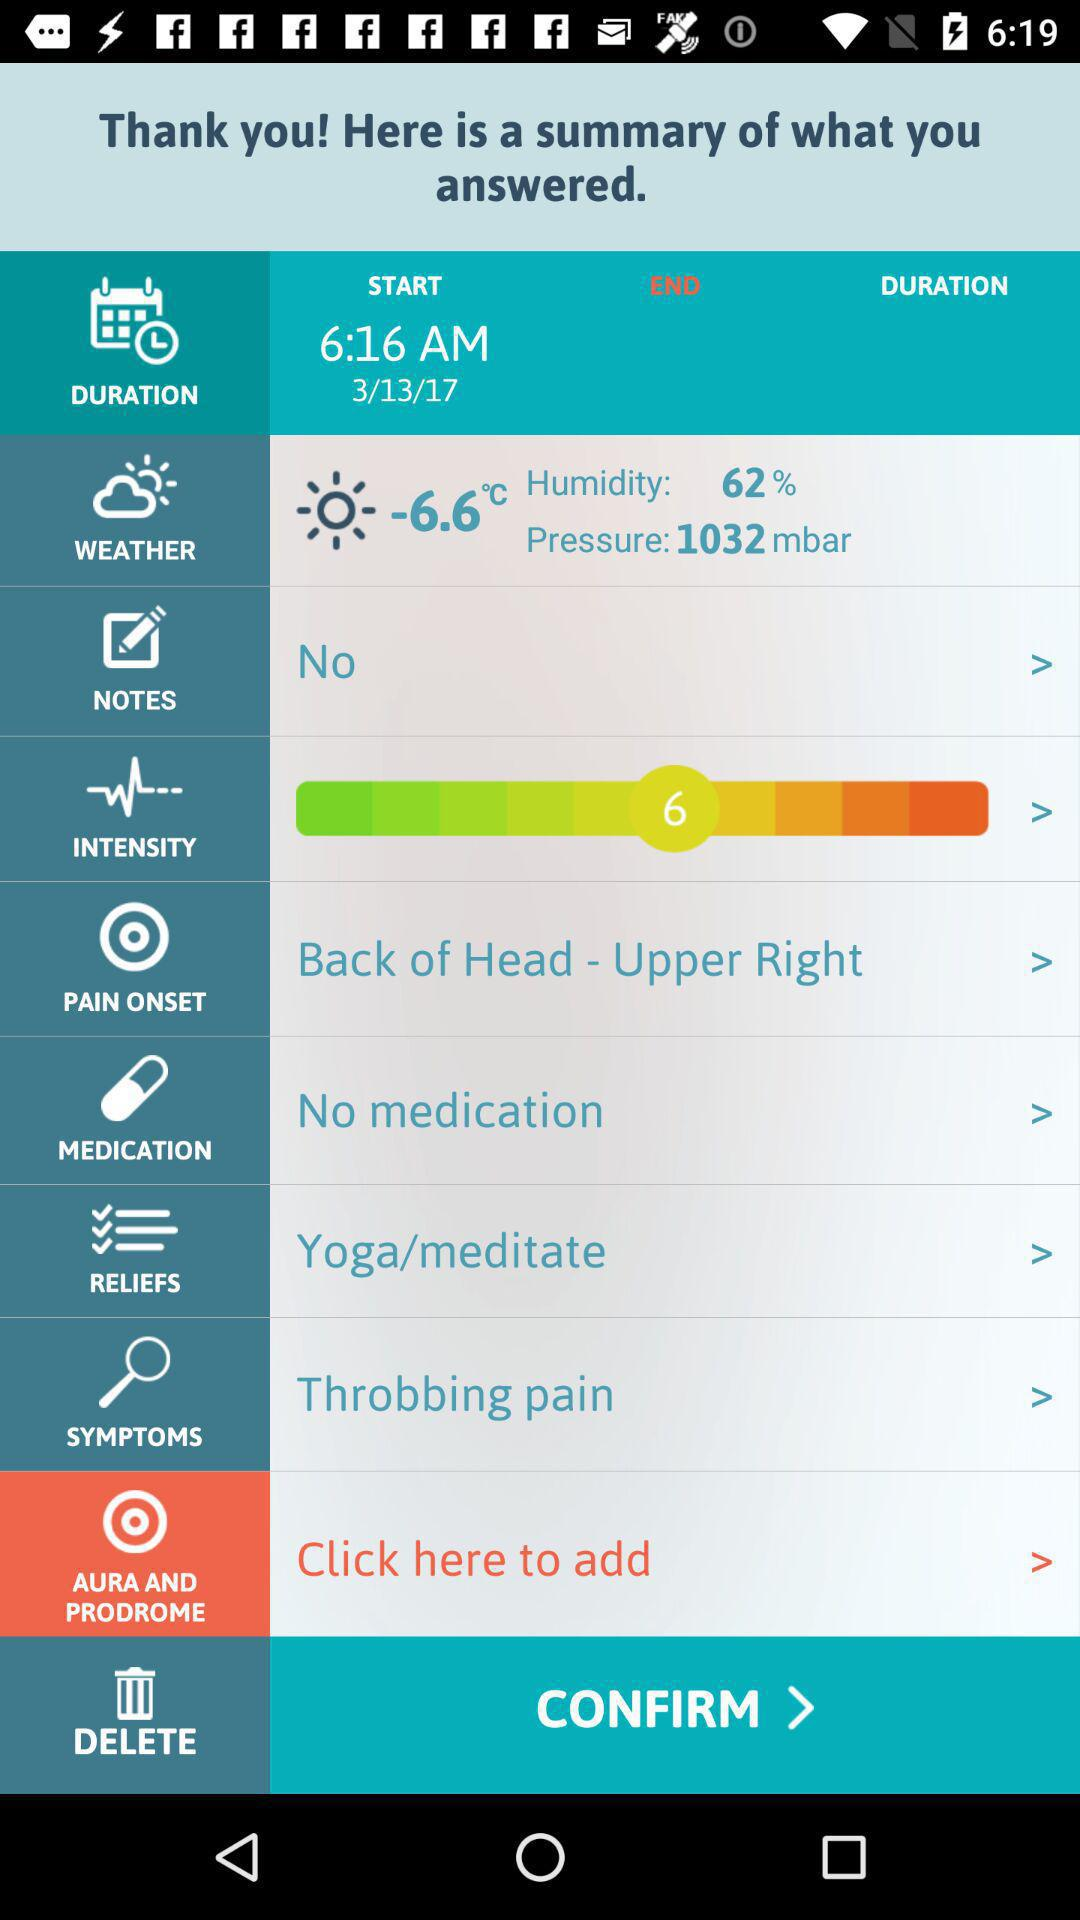What is the percentage of humidity? The percentage of humidity is 62. 